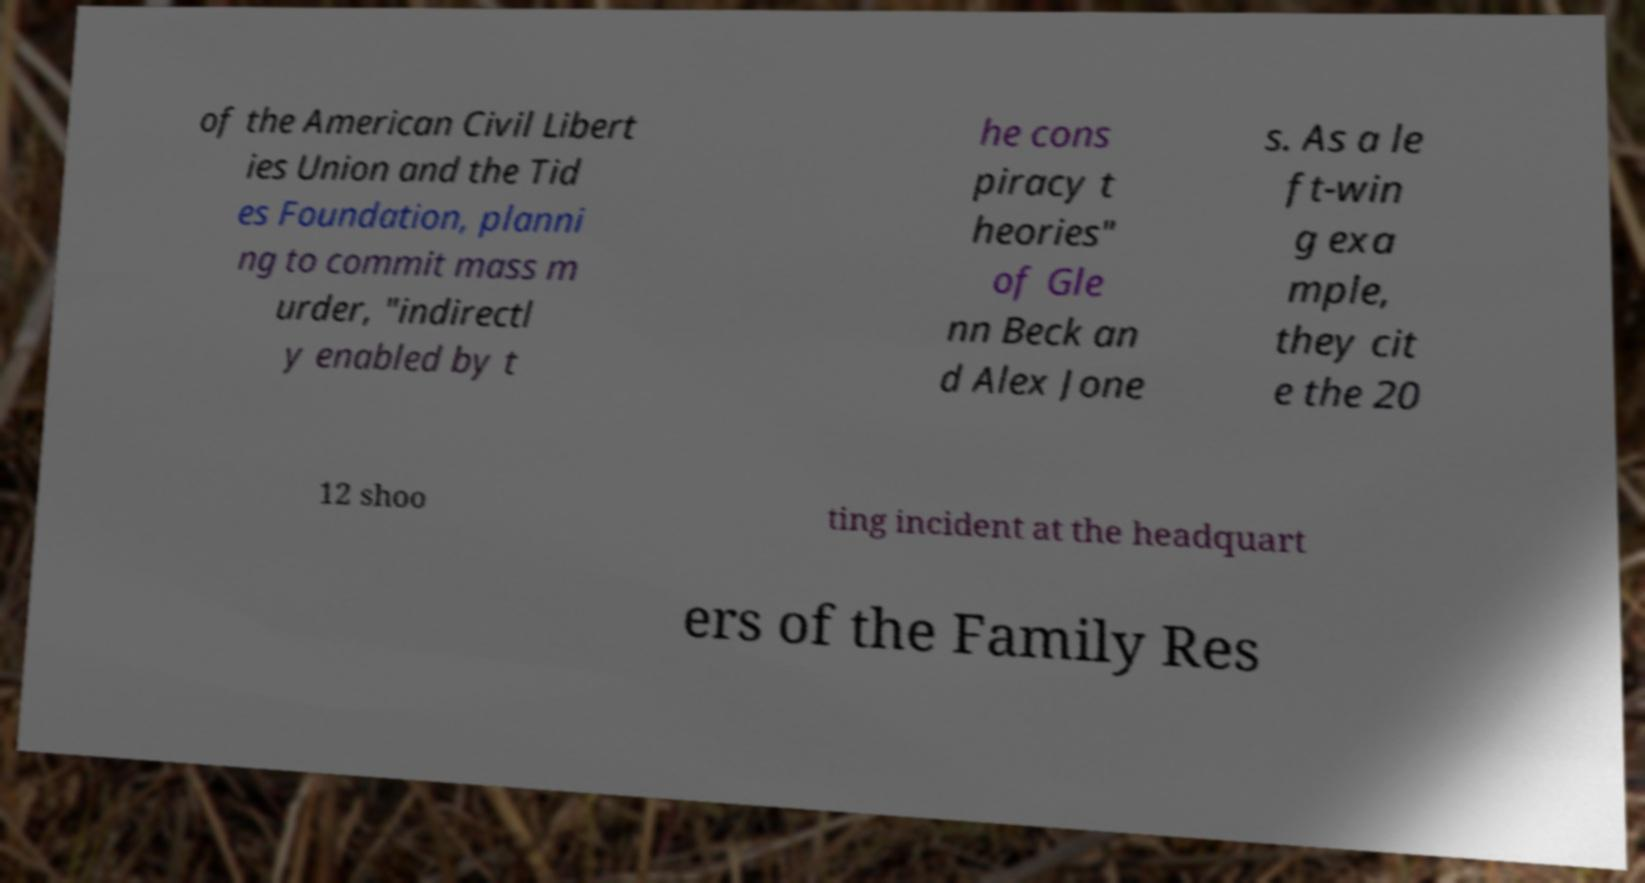Could you extract and type out the text from this image? of the American Civil Libert ies Union and the Tid es Foundation, planni ng to commit mass m urder, "indirectl y enabled by t he cons piracy t heories" of Gle nn Beck an d Alex Jone s. As a le ft-win g exa mple, they cit e the 20 12 shoo ting incident at the headquart ers of the Family Res 